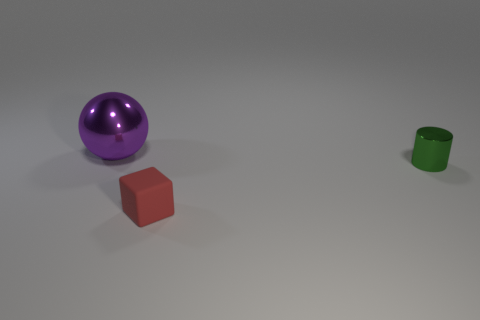The red object that is the same size as the green cylinder is what shape?
Your answer should be very brief. Cube. Are there any small things behind the red block?
Give a very brief answer. Yes. Is there another green thing that has the same shape as the small rubber thing?
Offer a very short reply. No. Do the metal thing that is on the right side of the large purple ball and the shiny object that is left of the tiny red matte object have the same shape?
Provide a succinct answer. No. Are there any red rubber objects that have the same size as the red matte cube?
Keep it short and to the point. No. Are there an equal number of red matte cubes that are behind the metallic cylinder and metallic spheres right of the red rubber cube?
Your response must be concise. Yes. Is the thing in front of the green cylinder made of the same material as the object that is on the left side of the tiny rubber thing?
Offer a terse response. No. What is the material of the small green object?
Offer a very short reply. Metal. What number of other things are there of the same color as the ball?
Your answer should be compact. 0. Does the metallic cylinder have the same color as the sphere?
Keep it short and to the point. No. 